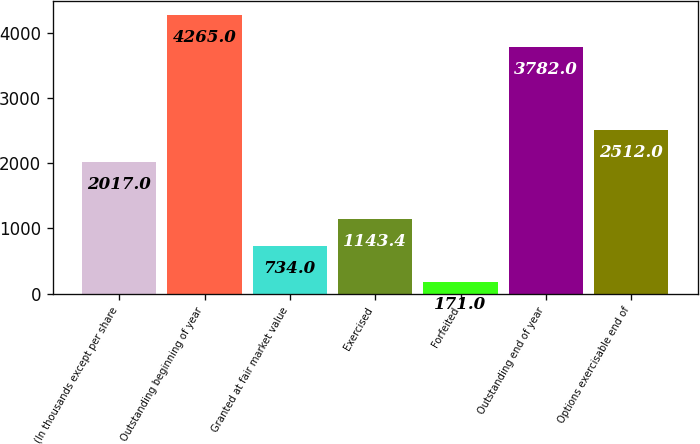Convert chart to OTSL. <chart><loc_0><loc_0><loc_500><loc_500><bar_chart><fcel>(In thousands except per share<fcel>Outstanding beginning of year<fcel>Granted at fair market value<fcel>Exercised<fcel>Forfeited<fcel>Outstanding end of year<fcel>Options exercisable end of<nl><fcel>2017<fcel>4265<fcel>734<fcel>1143.4<fcel>171<fcel>3782<fcel>2512<nl></chart> 